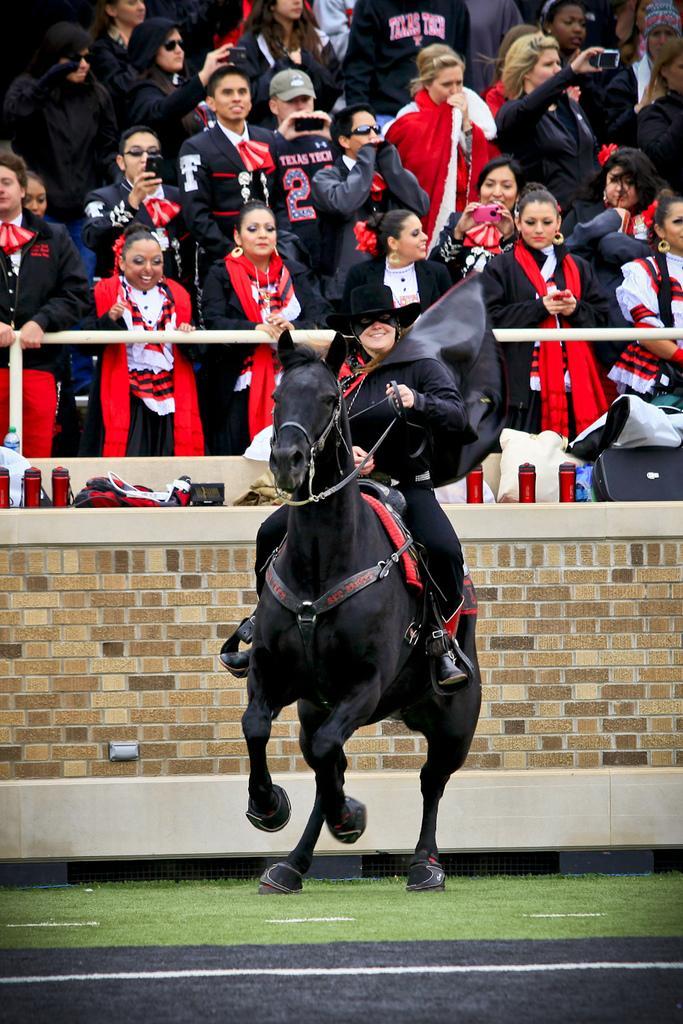Can you describe this image briefly? In the center of the picture there is a woman in black dress riding a black horse. At the bottom there is grass. In the background there are people watching. In the center there is a brick wall and there are water bottles and other objects on the wall. 